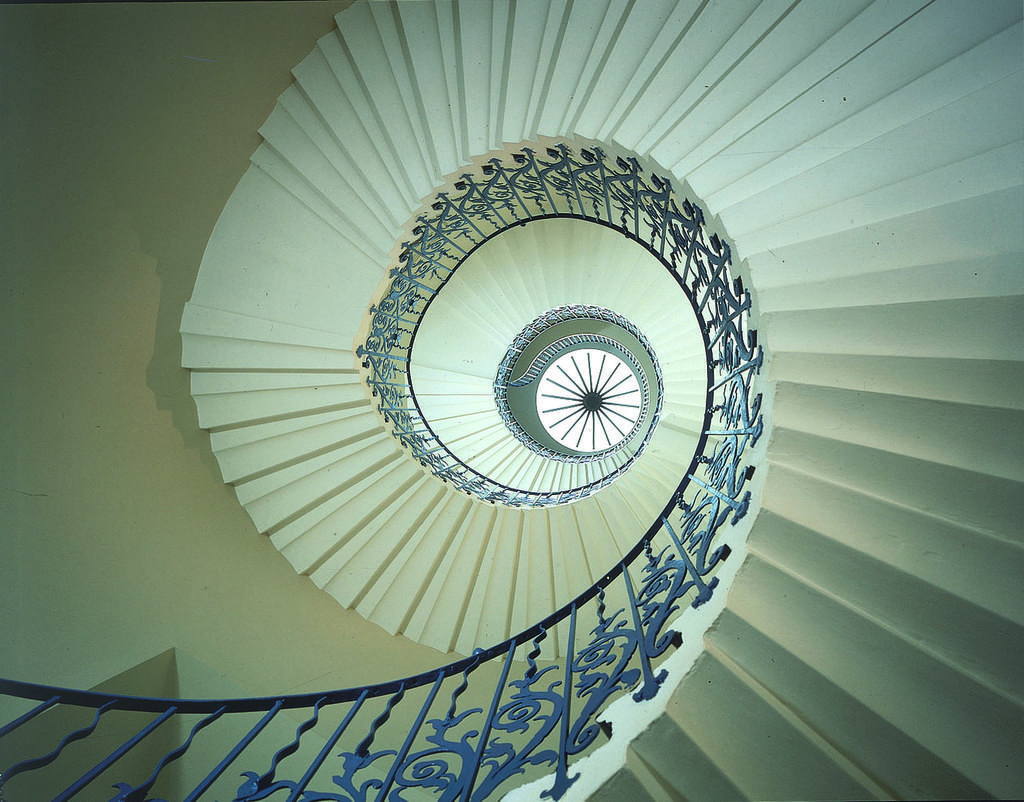What type of structure can be seen in the image? There is a railing and stairs in the image. What is the purpose of the railing in the image? The railing is likely there for safety and support while using the stairs. What can be seen in the background of the image? There is a wall in the background of the image. Can you tell me how many kittens are playing on the lift in the image? There is no lift or kittens present in the image; it features a railing and stairs with a wall in the background. 